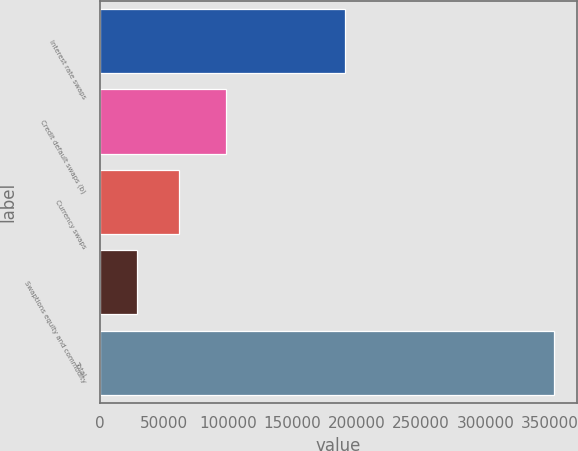Convert chart to OTSL. <chart><loc_0><loc_0><loc_500><loc_500><bar_chart><fcel>Interest rate swaps<fcel>Credit default swaps (b)<fcel>Currency swaps<fcel>Swaptions equity and commodity<fcel>Total<nl><fcel>190864<fcel>98398<fcel>61383.6<fcel>28907<fcel>353673<nl></chart> 